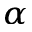<formula> <loc_0><loc_0><loc_500><loc_500>_ { \alpha }</formula> 